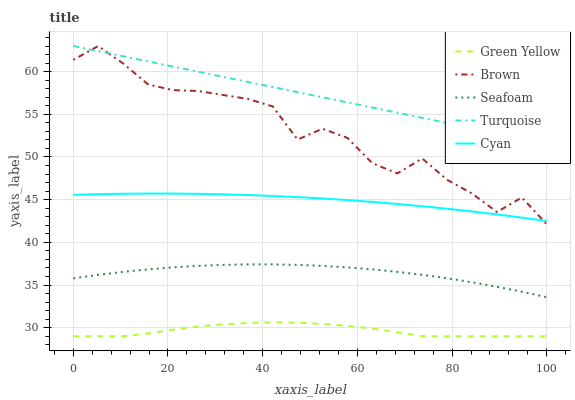Does Green Yellow have the minimum area under the curve?
Answer yes or no. Yes. Does Turquoise have the maximum area under the curve?
Answer yes or no. Yes. Does Turquoise have the minimum area under the curve?
Answer yes or no. No. Does Green Yellow have the maximum area under the curve?
Answer yes or no. No. Is Turquoise the smoothest?
Answer yes or no. Yes. Is Brown the roughest?
Answer yes or no. Yes. Is Green Yellow the smoothest?
Answer yes or no. No. Is Green Yellow the roughest?
Answer yes or no. No. Does Green Yellow have the lowest value?
Answer yes or no. Yes. Does Turquoise have the lowest value?
Answer yes or no. No. Does Turquoise have the highest value?
Answer yes or no. Yes. Does Green Yellow have the highest value?
Answer yes or no. No. Is Seafoam less than Brown?
Answer yes or no. Yes. Is Brown greater than Seafoam?
Answer yes or no. Yes. Does Turquoise intersect Brown?
Answer yes or no. Yes. Is Turquoise less than Brown?
Answer yes or no. No. Is Turquoise greater than Brown?
Answer yes or no. No. Does Seafoam intersect Brown?
Answer yes or no. No. 